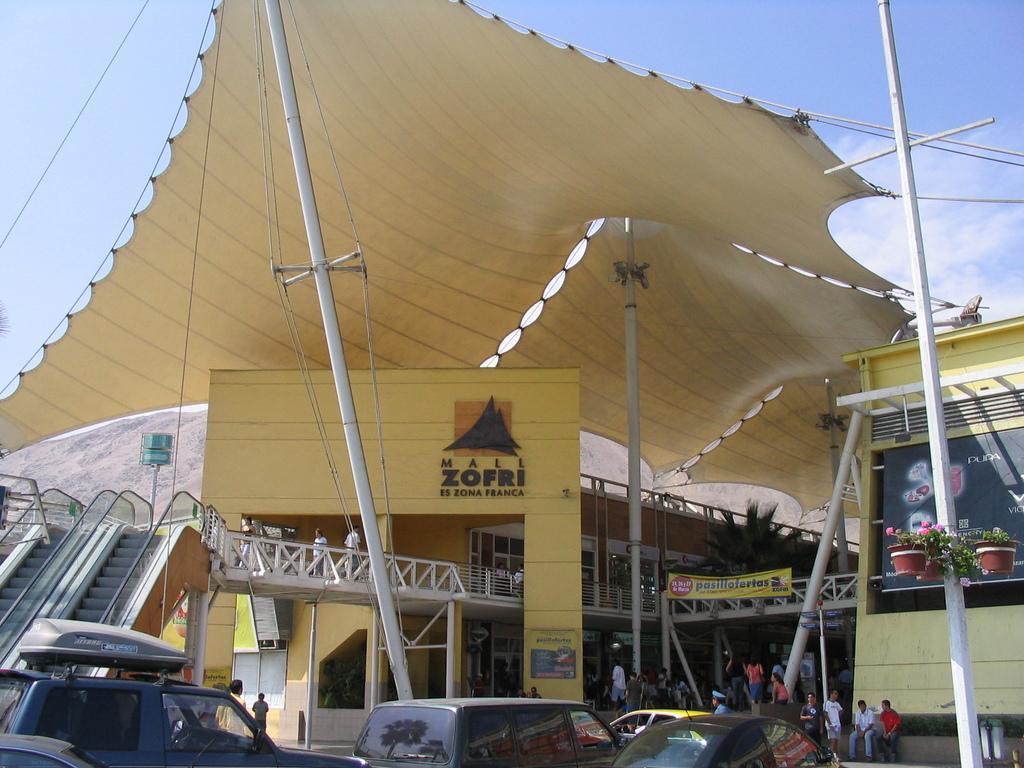Could you give a brief overview of what you see in this image? In this image we can see buildings with windows and names. Also there are poles and rods. And there is a tent. There are name boards. At the bottom there are vehicles. And there are many people. And there are pots with plants on a pole. And there is sky with clouds. And there are escalators. 